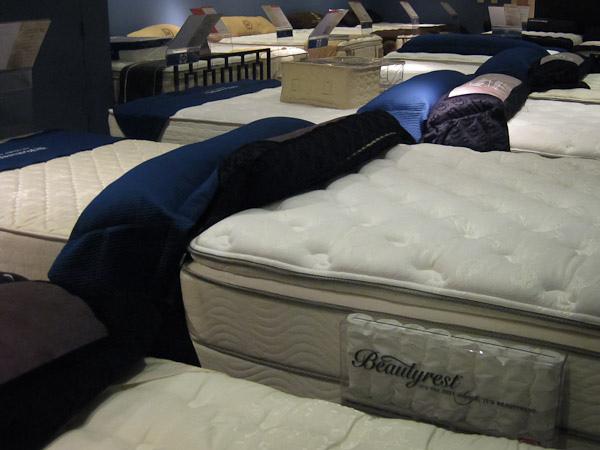What kind of mattress are those?
Give a very brief answer. Beautyrest. Do these beds have blankets?
Give a very brief answer. No. Are these mattresses for sale?
Be succinct. Yes. 